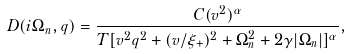<formula> <loc_0><loc_0><loc_500><loc_500>D ( i \Omega _ { n } , q ) = \frac { C ( v ^ { 2 } ) ^ { \alpha } } { T [ v ^ { 2 } q ^ { 2 } + ( v / \xi _ { + } ) ^ { 2 } + \Omega _ { n } ^ { 2 } + 2 \gamma | \Omega _ { n } | ] ^ { \alpha } } ,</formula> 